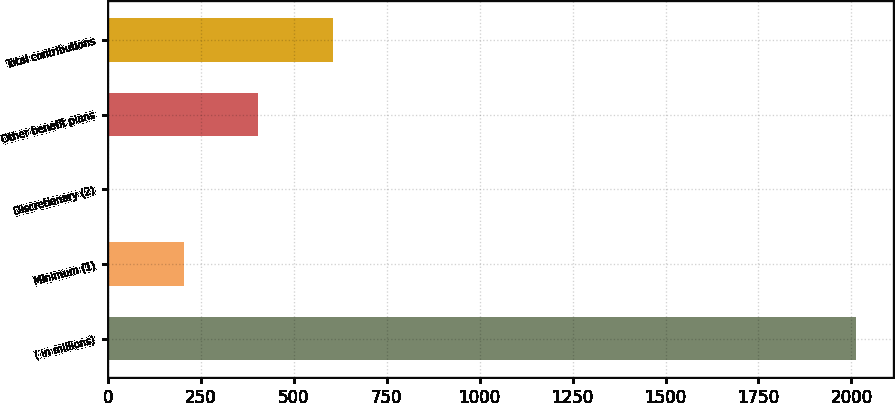<chart> <loc_0><loc_0><loc_500><loc_500><bar_chart><fcel>( in millions)<fcel>Minimum (1)<fcel>Discretionary (2)<fcel>Other benefit plans<fcel>Total contributions<nl><fcel>2011<fcel>203.8<fcel>3<fcel>404.6<fcel>605.4<nl></chart> 